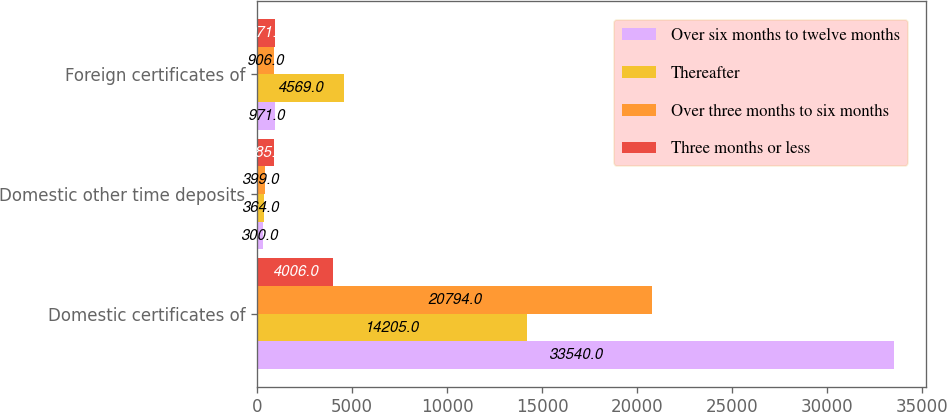Convert chart to OTSL. <chart><loc_0><loc_0><loc_500><loc_500><stacked_bar_chart><ecel><fcel>Domestic certificates of<fcel>Domestic other time deposits<fcel>Foreign certificates of<nl><fcel>Over six months to twelve months<fcel>33540<fcel>300<fcel>971<nl><fcel>Thereafter<fcel>14205<fcel>364<fcel>4569<nl><fcel>Over three months to six months<fcel>20794<fcel>399<fcel>906<nl><fcel>Three months or less<fcel>4006<fcel>885<fcel>971<nl></chart> 